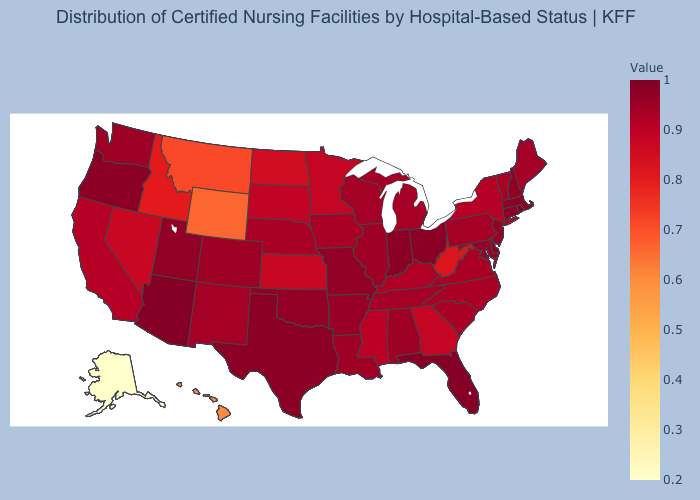Among the states that border Washington , which have the lowest value?
Short answer required. Idaho. Among the states that border Tennessee , does Missouri have the highest value?
Give a very brief answer. Yes. Among the states that border South Carolina , which have the highest value?
Concise answer only. North Carolina. Among the states that border North Carolina , does South Carolina have the highest value?
Concise answer only. No. Among the states that border Arizona , which have the highest value?
Quick response, please. Utah. Which states have the highest value in the USA?
Write a very short answer. Rhode Island. 